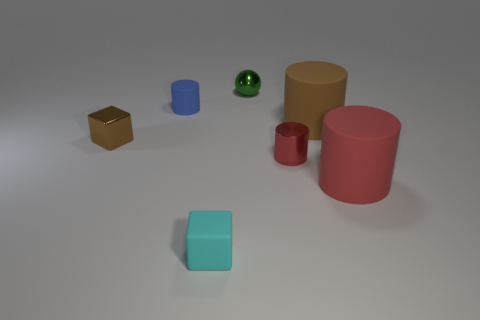Is the tiny cube that is on the right side of the tiny brown cube made of the same material as the small green sphere?
Your answer should be very brief. No. Are there any red rubber objects that have the same size as the rubber block?
Make the answer very short. No. There is a green metal object; is it the same shape as the red object on the right side of the brown cylinder?
Ensure brevity in your answer.  No. There is a red object right of the small cylinder that is in front of the tiny brown object; are there any things that are on the left side of it?
Your answer should be compact. Yes. The cyan rubber block has what size?
Your answer should be compact. Small. How many other objects are the same color as the metallic sphere?
Your response must be concise. 0. There is a small object to the right of the tiny green metal thing; is its shape the same as the small green metallic thing?
Ensure brevity in your answer.  No. The other large object that is the same shape as the big brown thing is what color?
Offer a terse response. Red. What is the size of the brown shiny object that is the same shape as the small cyan thing?
Offer a very short reply. Small. There is a tiny object that is both behind the tiny red thing and in front of the tiny blue matte object; what is its material?
Provide a short and direct response. Metal. 